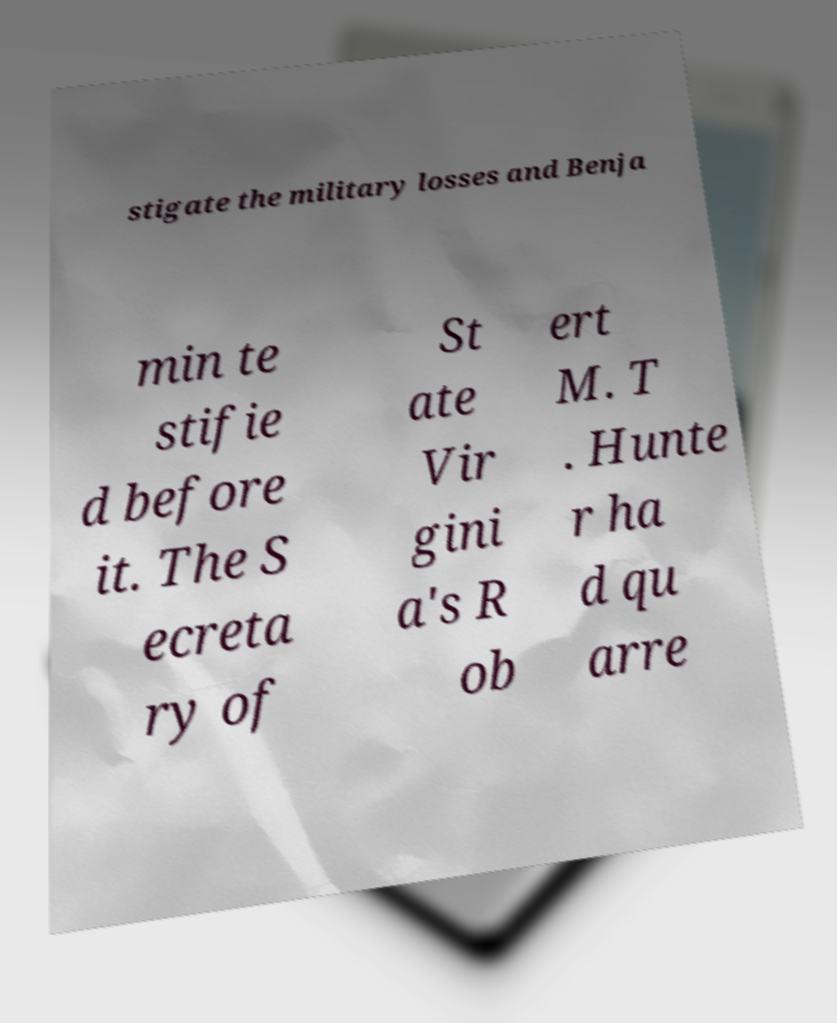Could you extract and type out the text from this image? stigate the military losses and Benja min te stifie d before it. The S ecreta ry of St ate Vir gini a's R ob ert M. T . Hunte r ha d qu arre 